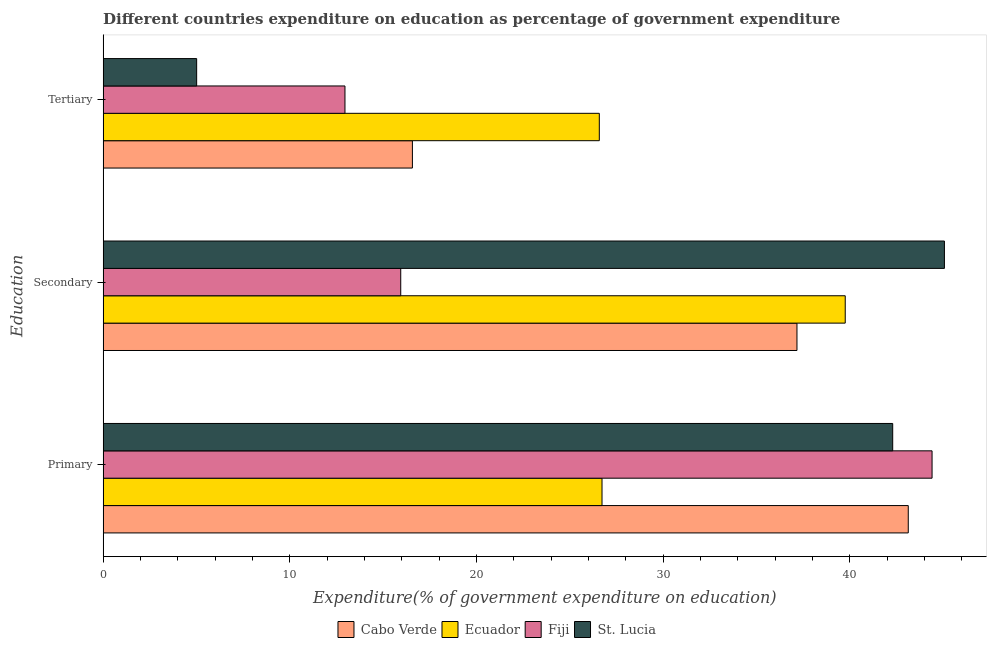How many different coloured bars are there?
Your response must be concise. 4. How many bars are there on the 1st tick from the bottom?
Keep it short and to the point. 4. What is the label of the 3rd group of bars from the top?
Ensure brevity in your answer.  Primary. What is the expenditure on tertiary education in St. Lucia?
Your answer should be compact. 5.01. Across all countries, what is the maximum expenditure on tertiary education?
Provide a succinct answer. 26.58. Across all countries, what is the minimum expenditure on secondary education?
Offer a terse response. 15.94. In which country was the expenditure on primary education maximum?
Give a very brief answer. Fiji. In which country was the expenditure on secondary education minimum?
Provide a succinct answer. Fiji. What is the total expenditure on tertiary education in the graph?
Your answer should be compact. 61.12. What is the difference between the expenditure on tertiary education in Fiji and that in Ecuador?
Offer a terse response. -13.63. What is the difference between the expenditure on tertiary education in Cabo Verde and the expenditure on secondary education in St. Lucia?
Offer a very short reply. -28.51. What is the average expenditure on secondary education per country?
Make the answer very short. 34.49. What is the difference between the expenditure on primary education and expenditure on secondary education in Ecuador?
Give a very brief answer. -13.03. What is the ratio of the expenditure on secondary education in Fiji to that in Ecuador?
Provide a short and direct response. 0.4. Is the expenditure on tertiary education in Fiji less than that in Cabo Verde?
Give a very brief answer. Yes. Is the difference between the expenditure on primary education in St. Lucia and Ecuador greater than the difference between the expenditure on tertiary education in St. Lucia and Ecuador?
Your answer should be compact. Yes. What is the difference between the highest and the second highest expenditure on tertiary education?
Offer a very short reply. 10.01. What is the difference between the highest and the lowest expenditure on tertiary education?
Your answer should be very brief. 21.57. Is the sum of the expenditure on primary education in Fiji and St. Lucia greater than the maximum expenditure on secondary education across all countries?
Provide a short and direct response. Yes. What does the 4th bar from the top in Primary represents?
Make the answer very short. Cabo Verde. What does the 3rd bar from the bottom in Tertiary represents?
Provide a succinct answer. Fiji. How many bars are there?
Provide a succinct answer. 12. Are all the bars in the graph horizontal?
Ensure brevity in your answer.  Yes. How many countries are there in the graph?
Offer a very short reply. 4. Are the values on the major ticks of X-axis written in scientific E-notation?
Keep it short and to the point. No. Where does the legend appear in the graph?
Offer a very short reply. Bottom center. What is the title of the graph?
Ensure brevity in your answer.  Different countries expenditure on education as percentage of government expenditure. What is the label or title of the X-axis?
Your response must be concise. Expenditure(% of government expenditure on education). What is the label or title of the Y-axis?
Provide a succinct answer. Education. What is the Expenditure(% of government expenditure on education) of Cabo Verde in Primary?
Ensure brevity in your answer.  43.14. What is the Expenditure(% of government expenditure on education) in Ecuador in Primary?
Offer a terse response. 26.73. What is the Expenditure(% of government expenditure on education) of Fiji in Primary?
Provide a succinct answer. 44.41. What is the Expenditure(% of government expenditure on education) of St. Lucia in Primary?
Provide a succinct answer. 42.3. What is the Expenditure(% of government expenditure on education) in Cabo Verde in Secondary?
Your response must be concise. 37.17. What is the Expenditure(% of government expenditure on education) of Ecuador in Secondary?
Offer a very short reply. 39.76. What is the Expenditure(% of government expenditure on education) of Fiji in Secondary?
Offer a terse response. 15.94. What is the Expenditure(% of government expenditure on education) in St. Lucia in Secondary?
Give a very brief answer. 45.08. What is the Expenditure(% of government expenditure on education) in Cabo Verde in Tertiary?
Your response must be concise. 16.57. What is the Expenditure(% of government expenditure on education) in Ecuador in Tertiary?
Offer a terse response. 26.58. What is the Expenditure(% of government expenditure on education) of Fiji in Tertiary?
Offer a terse response. 12.96. What is the Expenditure(% of government expenditure on education) of St. Lucia in Tertiary?
Your answer should be compact. 5.01. Across all Education, what is the maximum Expenditure(% of government expenditure on education) in Cabo Verde?
Give a very brief answer. 43.14. Across all Education, what is the maximum Expenditure(% of government expenditure on education) of Ecuador?
Offer a very short reply. 39.76. Across all Education, what is the maximum Expenditure(% of government expenditure on education) of Fiji?
Your answer should be compact. 44.41. Across all Education, what is the maximum Expenditure(% of government expenditure on education) in St. Lucia?
Your answer should be very brief. 45.08. Across all Education, what is the minimum Expenditure(% of government expenditure on education) of Cabo Verde?
Your response must be concise. 16.57. Across all Education, what is the minimum Expenditure(% of government expenditure on education) in Ecuador?
Offer a very short reply. 26.58. Across all Education, what is the minimum Expenditure(% of government expenditure on education) of Fiji?
Provide a succinct answer. 12.96. Across all Education, what is the minimum Expenditure(% of government expenditure on education) of St. Lucia?
Give a very brief answer. 5.01. What is the total Expenditure(% of government expenditure on education) in Cabo Verde in the graph?
Your answer should be compact. 96.88. What is the total Expenditure(% of government expenditure on education) of Ecuador in the graph?
Provide a succinct answer. 93.07. What is the total Expenditure(% of government expenditure on education) of Fiji in the graph?
Give a very brief answer. 73.31. What is the total Expenditure(% of government expenditure on education) in St. Lucia in the graph?
Make the answer very short. 92.39. What is the difference between the Expenditure(% of government expenditure on education) of Cabo Verde in Primary and that in Secondary?
Your answer should be very brief. 5.96. What is the difference between the Expenditure(% of government expenditure on education) of Ecuador in Primary and that in Secondary?
Offer a terse response. -13.03. What is the difference between the Expenditure(% of government expenditure on education) of Fiji in Primary and that in Secondary?
Make the answer very short. 28.47. What is the difference between the Expenditure(% of government expenditure on education) of St. Lucia in Primary and that in Secondary?
Offer a very short reply. -2.77. What is the difference between the Expenditure(% of government expenditure on education) in Cabo Verde in Primary and that in Tertiary?
Give a very brief answer. 26.57. What is the difference between the Expenditure(% of government expenditure on education) in Ecuador in Primary and that in Tertiary?
Your response must be concise. 0.14. What is the difference between the Expenditure(% of government expenditure on education) of Fiji in Primary and that in Tertiary?
Offer a very short reply. 31.46. What is the difference between the Expenditure(% of government expenditure on education) of St. Lucia in Primary and that in Tertiary?
Give a very brief answer. 37.29. What is the difference between the Expenditure(% of government expenditure on education) in Cabo Verde in Secondary and that in Tertiary?
Your response must be concise. 20.6. What is the difference between the Expenditure(% of government expenditure on education) of Ecuador in Secondary and that in Tertiary?
Your answer should be very brief. 13.18. What is the difference between the Expenditure(% of government expenditure on education) of Fiji in Secondary and that in Tertiary?
Provide a succinct answer. 2.99. What is the difference between the Expenditure(% of government expenditure on education) of St. Lucia in Secondary and that in Tertiary?
Ensure brevity in your answer.  40.06. What is the difference between the Expenditure(% of government expenditure on education) of Cabo Verde in Primary and the Expenditure(% of government expenditure on education) of Ecuador in Secondary?
Offer a terse response. 3.38. What is the difference between the Expenditure(% of government expenditure on education) in Cabo Verde in Primary and the Expenditure(% of government expenditure on education) in Fiji in Secondary?
Keep it short and to the point. 27.19. What is the difference between the Expenditure(% of government expenditure on education) of Cabo Verde in Primary and the Expenditure(% of government expenditure on education) of St. Lucia in Secondary?
Give a very brief answer. -1.94. What is the difference between the Expenditure(% of government expenditure on education) in Ecuador in Primary and the Expenditure(% of government expenditure on education) in Fiji in Secondary?
Offer a very short reply. 10.78. What is the difference between the Expenditure(% of government expenditure on education) in Ecuador in Primary and the Expenditure(% of government expenditure on education) in St. Lucia in Secondary?
Make the answer very short. -18.35. What is the difference between the Expenditure(% of government expenditure on education) of Fiji in Primary and the Expenditure(% of government expenditure on education) of St. Lucia in Secondary?
Provide a succinct answer. -0.66. What is the difference between the Expenditure(% of government expenditure on education) in Cabo Verde in Primary and the Expenditure(% of government expenditure on education) in Ecuador in Tertiary?
Your answer should be very brief. 16.55. What is the difference between the Expenditure(% of government expenditure on education) of Cabo Verde in Primary and the Expenditure(% of government expenditure on education) of Fiji in Tertiary?
Provide a succinct answer. 30.18. What is the difference between the Expenditure(% of government expenditure on education) of Cabo Verde in Primary and the Expenditure(% of government expenditure on education) of St. Lucia in Tertiary?
Keep it short and to the point. 38.13. What is the difference between the Expenditure(% of government expenditure on education) in Ecuador in Primary and the Expenditure(% of government expenditure on education) in Fiji in Tertiary?
Give a very brief answer. 13.77. What is the difference between the Expenditure(% of government expenditure on education) in Ecuador in Primary and the Expenditure(% of government expenditure on education) in St. Lucia in Tertiary?
Your answer should be very brief. 21.72. What is the difference between the Expenditure(% of government expenditure on education) of Fiji in Primary and the Expenditure(% of government expenditure on education) of St. Lucia in Tertiary?
Your answer should be compact. 39.4. What is the difference between the Expenditure(% of government expenditure on education) in Cabo Verde in Secondary and the Expenditure(% of government expenditure on education) in Ecuador in Tertiary?
Your answer should be compact. 10.59. What is the difference between the Expenditure(% of government expenditure on education) in Cabo Verde in Secondary and the Expenditure(% of government expenditure on education) in Fiji in Tertiary?
Offer a very short reply. 24.22. What is the difference between the Expenditure(% of government expenditure on education) in Cabo Verde in Secondary and the Expenditure(% of government expenditure on education) in St. Lucia in Tertiary?
Ensure brevity in your answer.  32.16. What is the difference between the Expenditure(% of government expenditure on education) of Ecuador in Secondary and the Expenditure(% of government expenditure on education) of Fiji in Tertiary?
Your response must be concise. 26.8. What is the difference between the Expenditure(% of government expenditure on education) in Ecuador in Secondary and the Expenditure(% of government expenditure on education) in St. Lucia in Tertiary?
Provide a short and direct response. 34.75. What is the difference between the Expenditure(% of government expenditure on education) of Fiji in Secondary and the Expenditure(% of government expenditure on education) of St. Lucia in Tertiary?
Your response must be concise. 10.93. What is the average Expenditure(% of government expenditure on education) in Cabo Verde per Education?
Provide a short and direct response. 32.29. What is the average Expenditure(% of government expenditure on education) in Ecuador per Education?
Offer a terse response. 31.02. What is the average Expenditure(% of government expenditure on education) in Fiji per Education?
Your response must be concise. 24.44. What is the average Expenditure(% of government expenditure on education) of St. Lucia per Education?
Your answer should be very brief. 30.8. What is the difference between the Expenditure(% of government expenditure on education) of Cabo Verde and Expenditure(% of government expenditure on education) of Ecuador in Primary?
Provide a succinct answer. 16.41. What is the difference between the Expenditure(% of government expenditure on education) of Cabo Verde and Expenditure(% of government expenditure on education) of Fiji in Primary?
Your response must be concise. -1.27. What is the difference between the Expenditure(% of government expenditure on education) of Cabo Verde and Expenditure(% of government expenditure on education) of St. Lucia in Primary?
Ensure brevity in your answer.  0.83. What is the difference between the Expenditure(% of government expenditure on education) in Ecuador and Expenditure(% of government expenditure on education) in Fiji in Primary?
Ensure brevity in your answer.  -17.68. What is the difference between the Expenditure(% of government expenditure on education) in Ecuador and Expenditure(% of government expenditure on education) in St. Lucia in Primary?
Offer a very short reply. -15.58. What is the difference between the Expenditure(% of government expenditure on education) of Fiji and Expenditure(% of government expenditure on education) of St. Lucia in Primary?
Your answer should be compact. 2.11. What is the difference between the Expenditure(% of government expenditure on education) of Cabo Verde and Expenditure(% of government expenditure on education) of Ecuador in Secondary?
Your answer should be compact. -2.59. What is the difference between the Expenditure(% of government expenditure on education) in Cabo Verde and Expenditure(% of government expenditure on education) in Fiji in Secondary?
Your response must be concise. 21.23. What is the difference between the Expenditure(% of government expenditure on education) in Cabo Verde and Expenditure(% of government expenditure on education) in St. Lucia in Secondary?
Your response must be concise. -7.9. What is the difference between the Expenditure(% of government expenditure on education) in Ecuador and Expenditure(% of government expenditure on education) in Fiji in Secondary?
Ensure brevity in your answer.  23.82. What is the difference between the Expenditure(% of government expenditure on education) in Ecuador and Expenditure(% of government expenditure on education) in St. Lucia in Secondary?
Provide a short and direct response. -5.32. What is the difference between the Expenditure(% of government expenditure on education) in Fiji and Expenditure(% of government expenditure on education) in St. Lucia in Secondary?
Give a very brief answer. -29.13. What is the difference between the Expenditure(% of government expenditure on education) in Cabo Verde and Expenditure(% of government expenditure on education) in Ecuador in Tertiary?
Your answer should be compact. -10.01. What is the difference between the Expenditure(% of government expenditure on education) in Cabo Verde and Expenditure(% of government expenditure on education) in Fiji in Tertiary?
Your answer should be very brief. 3.61. What is the difference between the Expenditure(% of government expenditure on education) in Cabo Verde and Expenditure(% of government expenditure on education) in St. Lucia in Tertiary?
Make the answer very short. 11.56. What is the difference between the Expenditure(% of government expenditure on education) of Ecuador and Expenditure(% of government expenditure on education) of Fiji in Tertiary?
Give a very brief answer. 13.63. What is the difference between the Expenditure(% of government expenditure on education) in Ecuador and Expenditure(% of government expenditure on education) in St. Lucia in Tertiary?
Offer a terse response. 21.57. What is the difference between the Expenditure(% of government expenditure on education) of Fiji and Expenditure(% of government expenditure on education) of St. Lucia in Tertiary?
Give a very brief answer. 7.95. What is the ratio of the Expenditure(% of government expenditure on education) in Cabo Verde in Primary to that in Secondary?
Provide a short and direct response. 1.16. What is the ratio of the Expenditure(% of government expenditure on education) of Ecuador in Primary to that in Secondary?
Keep it short and to the point. 0.67. What is the ratio of the Expenditure(% of government expenditure on education) in Fiji in Primary to that in Secondary?
Keep it short and to the point. 2.79. What is the ratio of the Expenditure(% of government expenditure on education) of St. Lucia in Primary to that in Secondary?
Your response must be concise. 0.94. What is the ratio of the Expenditure(% of government expenditure on education) in Cabo Verde in Primary to that in Tertiary?
Offer a very short reply. 2.6. What is the ratio of the Expenditure(% of government expenditure on education) in Ecuador in Primary to that in Tertiary?
Provide a short and direct response. 1.01. What is the ratio of the Expenditure(% of government expenditure on education) in Fiji in Primary to that in Tertiary?
Offer a terse response. 3.43. What is the ratio of the Expenditure(% of government expenditure on education) in St. Lucia in Primary to that in Tertiary?
Your response must be concise. 8.44. What is the ratio of the Expenditure(% of government expenditure on education) of Cabo Verde in Secondary to that in Tertiary?
Your response must be concise. 2.24. What is the ratio of the Expenditure(% of government expenditure on education) of Ecuador in Secondary to that in Tertiary?
Your response must be concise. 1.5. What is the ratio of the Expenditure(% of government expenditure on education) of Fiji in Secondary to that in Tertiary?
Give a very brief answer. 1.23. What is the ratio of the Expenditure(% of government expenditure on education) in St. Lucia in Secondary to that in Tertiary?
Provide a short and direct response. 9. What is the difference between the highest and the second highest Expenditure(% of government expenditure on education) of Cabo Verde?
Offer a terse response. 5.96. What is the difference between the highest and the second highest Expenditure(% of government expenditure on education) in Ecuador?
Ensure brevity in your answer.  13.03. What is the difference between the highest and the second highest Expenditure(% of government expenditure on education) of Fiji?
Ensure brevity in your answer.  28.47. What is the difference between the highest and the second highest Expenditure(% of government expenditure on education) of St. Lucia?
Ensure brevity in your answer.  2.77. What is the difference between the highest and the lowest Expenditure(% of government expenditure on education) of Cabo Verde?
Give a very brief answer. 26.57. What is the difference between the highest and the lowest Expenditure(% of government expenditure on education) of Ecuador?
Your answer should be very brief. 13.18. What is the difference between the highest and the lowest Expenditure(% of government expenditure on education) in Fiji?
Make the answer very short. 31.46. What is the difference between the highest and the lowest Expenditure(% of government expenditure on education) in St. Lucia?
Offer a very short reply. 40.06. 